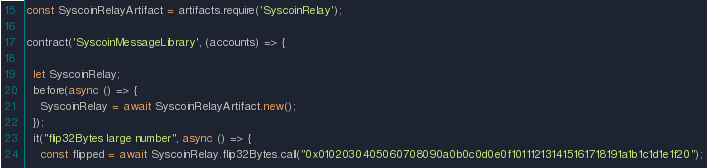<code> <loc_0><loc_0><loc_500><loc_500><_JavaScript_>const SyscoinRelayArtifact = artifacts.require('SyscoinRelay');

contract('SyscoinMessageLibrary', (accounts) => {

  let SyscoinRelay;
  before(async () => {
    SyscoinRelay = await SyscoinRelayArtifact.new();
  });
  it("flip32Bytes large number", async () => {
    const flipped = await SyscoinRelay.flip32Bytes.call("0x0102030405060708090a0b0c0d0e0f101112131415161718191a1b1c1d1e1f20");</code> 